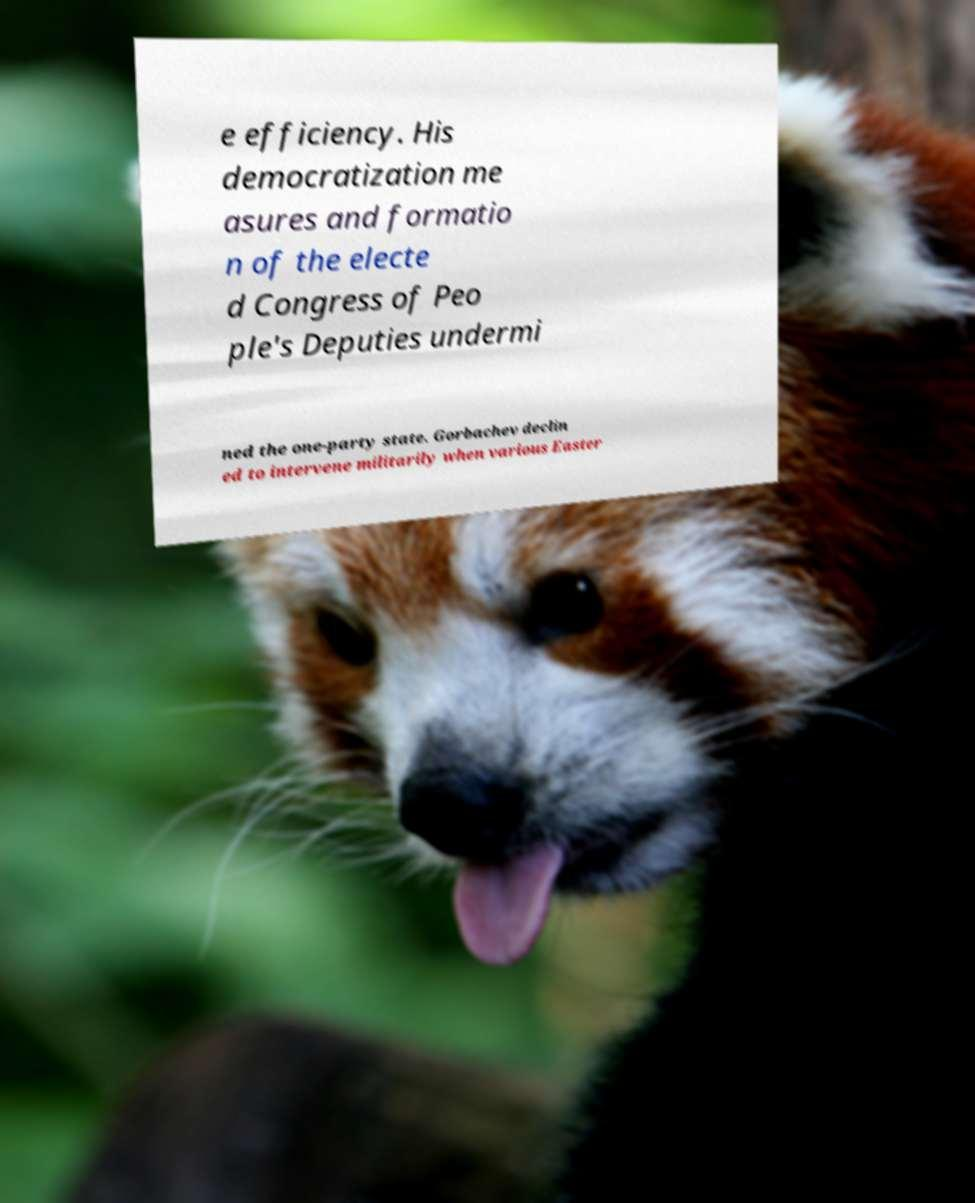Can you read and provide the text displayed in the image?This photo seems to have some interesting text. Can you extract and type it out for me? e efficiency. His democratization me asures and formatio n of the electe d Congress of Peo ple's Deputies undermi ned the one-party state. Gorbachev declin ed to intervene militarily when various Easter 